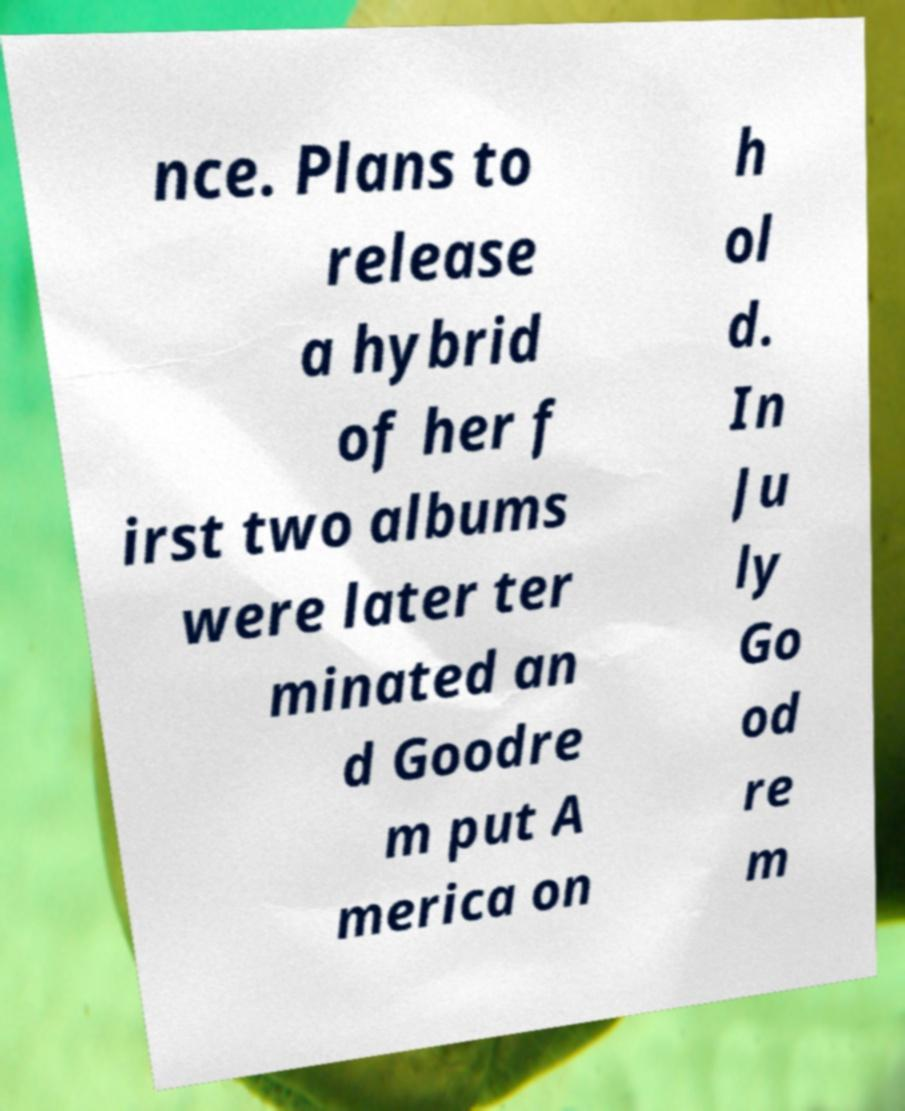Could you assist in decoding the text presented in this image and type it out clearly? nce. Plans to release a hybrid of her f irst two albums were later ter minated an d Goodre m put A merica on h ol d. In Ju ly Go od re m 